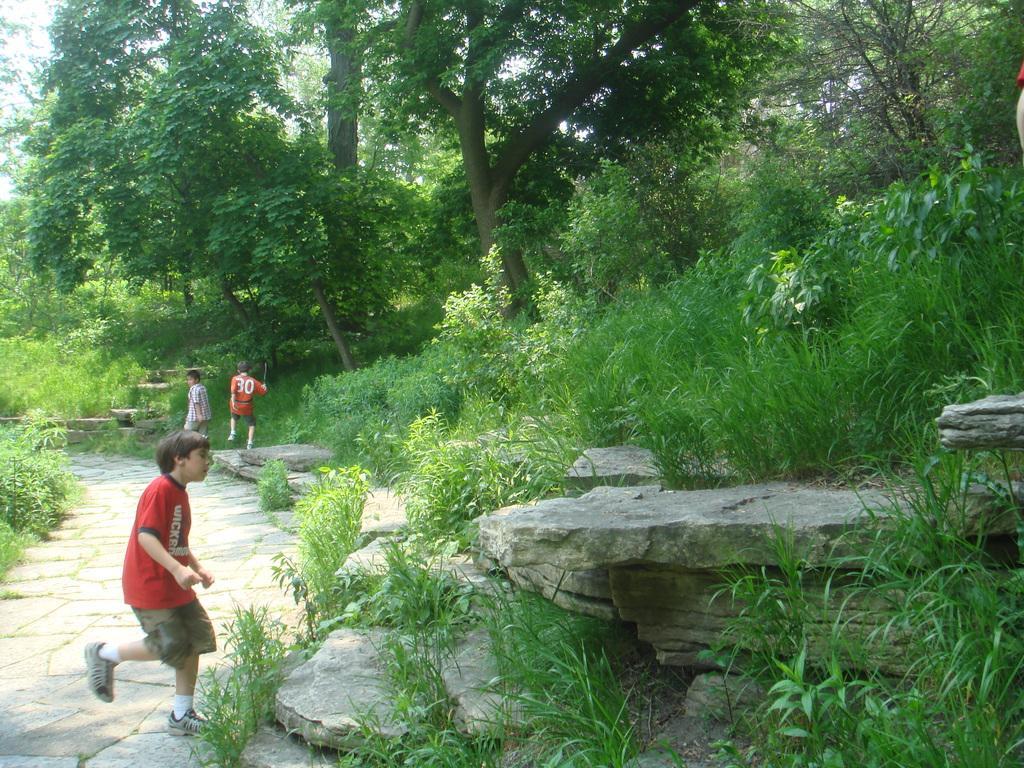Can you describe this image briefly? In this image I can see three persons. In front the person is wearing red and brown color dress. Background I can see few trees in green color and the sky is in white color. 